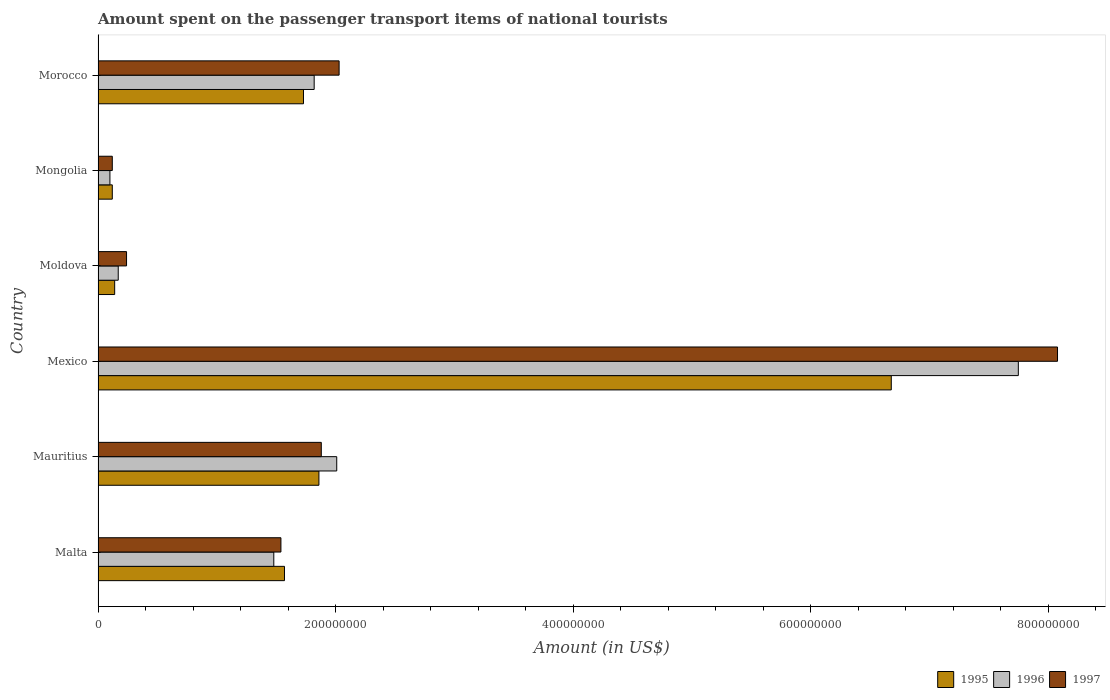Are the number of bars per tick equal to the number of legend labels?
Provide a succinct answer. Yes. How many bars are there on the 4th tick from the top?
Ensure brevity in your answer.  3. How many bars are there on the 1st tick from the bottom?
Give a very brief answer. 3. What is the label of the 3rd group of bars from the top?
Offer a very short reply. Moldova. What is the amount spent on the passenger transport items of national tourists in 1996 in Mauritius?
Offer a very short reply. 2.01e+08. Across all countries, what is the maximum amount spent on the passenger transport items of national tourists in 1995?
Your answer should be very brief. 6.68e+08. In which country was the amount spent on the passenger transport items of national tourists in 1995 minimum?
Ensure brevity in your answer.  Mongolia. What is the total amount spent on the passenger transport items of national tourists in 1995 in the graph?
Your answer should be compact. 1.21e+09. What is the difference between the amount spent on the passenger transport items of national tourists in 1995 in Mexico and that in Moldova?
Provide a short and direct response. 6.54e+08. What is the difference between the amount spent on the passenger transport items of national tourists in 1995 in Moldova and the amount spent on the passenger transport items of national tourists in 1997 in Mexico?
Your response must be concise. -7.94e+08. What is the average amount spent on the passenger transport items of national tourists in 1997 per country?
Keep it short and to the point. 2.32e+08. What is the ratio of the amount spent on the passenger transport items of national tourists in 1995 in Mauritius to that in Moldova?
Provide a succinct answer. 13.29. Is the difference between the amount spent on the passenger transport items of national tourists in 1995 in Mauritius and Mexico greater than the difference between the amount spent on the passenger transport items of national tourists in 1996 in Mauritius and Mexico?
Give a very brief answer. Yes. What is the difference between the highest and the second highest amount spent on the passenger transport items of national tourists in 1995?
Offer a very short reply. 4.82e+08. What is the difference between the highest and the lowest amount spent on the passenger transport items of national tourists in 1997?
Provide a succinct answer. 7.96e+08. Is the sum of the amount spent on the passenger transport items of national tourists in 1995 in Mauritius and Mongolia greater than the maximum amount spent on the passenger transport items of national tourists in 1996 across all countries?
Your answer should be very brief. No. What does the 2nd bar from the top in Malta represents?
Provide a short and direct response. 1996. Are all the bars in the graph horizontal?
Make the answer very short. Yes. How many countries are there in the graph?
Keep it short and to the point. 6. Does the graph contain any zero values?
Your response must be concise. No. Does the graph contain grids?
Your response must be concise. No. Where does the legend appear in the graph?
Offer a very short reply. Bottom right. How are the legend labels stacked?
Make the answer very short. Horizontal. What is the title of the graph?
Make the answer very short. Amount spent on the passenger transport items of national tourists. Does "2004" appear as one of the legend labels in the graph?
Offer a terse response. No. What is the label or title of the Y-axis?
Keep it short and to the point. Country. What is the Amount (in US$) of 1995 in Malta?
Offer a terse response. 1.57e+08. What is the Amount (in US$) in 1996 in Malta?
Provide a succinct answer. 1.48e+08. What is the Amount (in US$) in 1997 in Malta?
Your answer should be very brief. 1.54e+08. What is the Amount (in US$) in 1995 in Mauritius?
Provide a succinct answer. 1.86e+08. What is the Amount (in US$) in 1996 in Mauritius?
Offer a very short reply. 2.01e+08. What is the Amount (in US$) of 1997 in Mauritius?
Give a very brief answer. 1.88e+08. What is the Amount (in US$) in 1995 in Mexico?
Give a very brief answer. 6.68e+08. What is the Amount (in US$) in 1996 in Mexico?
Your response must be concise. 7.75e+08. What is the Amount (in US$) in 1997 in Mexico?
Ensure brevity in your answer.  8.08e+08. What is the Amount (in US$) in 1995 in Moldova?
Ensure brevity in your answer.  1.40e+07. What is the Amount (in US$) in 1996 in Moldova?
Make the answer very short. 1.70e+07. What is the Amount (in US$) of 1997 in Moldova?
Offer a very short reply. 2.40e+07. What is the Amount (in US$) of 1995 in Morocco?
Offer a terse response. 1.73e+08. What is the Amount (in US$) in 1996 in Morocco?
Offer a terse response. 1.82e+08. What is the Amount (in US$) in 1997 in Morocco?
Your response must be concise. 2.03e+08. Across all countries, what is the maximum Amount (in US$) in 1995?
Keep it short and to the point. 6.68e+08. Across all countries, what is the maximum Amount (in US$) of 1996?
Offer a very short reply. 7.75e+08. Across all countries, what is the maximum Amount (in US$) of 1997?
Ensure brevity in your answer.  8.08e+08. Across all countries, what is the minimum Amount (in US$) in 1995?
Offer a terse response. 1.20e+07. Across all countries, what is the minimum Amount (in US$) of 1996?
Your answer should be very brief. 1.00e+07. What is the total Amount (in US$) in 1995 in the graph?
Ensure brevity in your answer.  1.21e+09. What is the total Amount (in US$) in 1996 in the graph?
Keep it short and to the point. 1.33e+09. What is the total Amount (in US$) in 1997 in the graph?
Your answer should be very brief. 1.39e+09. What is the difference between the Amount (in US$) in 1995 in Malta and that in Mauritius?
Offer a very short reply. -2.90e+07. What is the difference between the Amount (in US$) in 1996 in Malta and that in Mauritius?
Your answer should be compact. -5.30e+07. What is the difference between the Amount (in US$) in 1997 in Malta and that in Mauritius?
Give a very brief answer. -3.40e+07. What is the difference between the Amount (in US$) of 1995 in Malta and that in Mexico?
Your answer should be compact. -5.11e+08. What is the difference between the Amount (in US$) of 1996 in Malta and that in Mexico?
Make the answer very short. -6.27e+08. What is the difference between the Amount (in US$) of 1997 in Malta and that in Mexico?
Offer a very short reply. -6.54e+08. What is the difference between the Amount (in US$) in 1995 in Malta and that in Moldova?
Your answer should be compact. 1.43e+08. What is the difference between the Amount (in US$) of 1996 in Malta and that in Moldova?
Your answer should be very brief. 1.31e+08. What is the difference between the Amount (in US$) in 1997 in Malta and that in Moldova?
Your answer should be compact. 1.30e+08. What is the difference between the Amount (in US$) in 1995 in Malta and that in Mongolia?
Offer a terse response. 1.45e+08. What is the difference between the Amount (in US$) of 1996 in Malta and that in Mongolia?
Provide a short and direct response. 1.38e+08. What is the difference between the Amount (in US$) of 1997 in Malta and that in Mongolia?
Your response must be concise. 1.42e+08. What is the difference between the Amount (in US$) of 1995 in Malta and that in Morocco?
Offer a terse response. -1.60e+07. What is the difference between the Amount (in US$) of 1996 in Malta and that in Morocco?
Provide a short and direct response. -3.40e+07. What is the difference between the Amount (in US$) of 1997 in Malta and that in Morocco?
Offer a terse response. -4.90e+07. What is the difference between the Amount (in US$) of 1995 in Mauritius and that in Mexico?
Offer a terse response. -4.82e+08. What is the difference between the Amount (in US$) of 1996 in Mauritius and that in Mexico?
Your response must be concise. -5.74e+08. What is the difference between the Amount (in US$) of 1997 in Mauritius and that in Mexico?
Make the answer very short. -6.20e+08. What is the difference between the Amount (in US$) in 1995 in Mauritius and that in Moldova?
Offer a very short reply. 1.72e+08. What is the difference between the Amount (in US$) of 1996 in Mauritius and that in Moldova?
Your answer should be very brief. 1.84e+08. What is the difference between the Amount (in US$) in 1997 in Mauritius and that in Moldova?
Keep it short and to the point. 1.64e+08. What is the difference between the Amount (in US$) in 1995 in Mauritius and that in Mongolia?
Offer a very short reply. 1.74e+08. What is the difference between the Amount (in US$) of 1996 in Mauritius and that in Mongolia?
Ensure brevity in your answer.  1.91e+08. What is the difference between the Amount (in US$) in 1997 in Mauritius and that in Mongolia?
Your answer should be very brief. 1.76e+08. What is the difference between the Amount (in US$) of 1995 in Mauritius and that in Morocco?
Offer a very short reply. 1.30e+07. What is the difference between the Amount (in US$) of 1996 in Mauritius and that in Morocco?
Provide a short and direct response. 1.90e+07. What is the difference between the Amount (in US$) of 1997 in Mauritius and that in Morocco?
Offer a very short reply. -1.50e+07. What is the difference between the Amount (in US$) of 1995 in Mexico and that in Moldova?
Offer a very short reply. 6.54e+08. What is the difference between the Amount (in US$) of 1996 in Mexico and that in Moldova?
Your answer should be very brief. 7.58e+08. What is the difference between the Amount (in US$) in 1997 in Mexico and that in Moldova?
Your answer should be very brief. 7.84e+08. What is the difference between the Amount (in US$) of 1995 in Mexico and that in Mongolia?
Your answer should be very brief. 6.56e+08. What is the difference between the Amount (in US$) of 1996 in Mexico and that in Mongolia?
Make the answer very short. 7.65e+08. What is the difference between the Amount (in US$) of 1997 in Mexico and that in Mongolia?
Your response must be concise. 7.96e+08. What is the difference between the Amount (in US$) of 1995 in Mexico and that in Morocco?
Offer a terse response. 4.95e+08. What is the difference between the Amount (in US$) in 1996 in Mexico and that in Morocco?
Your response must be concise. 5.93e+08. What is the difference between the Amount (in US$) in 1997 in Mexico and that in Morocco?
Offer a terse response. 6.05e+08. What is the difference between the Amount (in US$) in 1995 in Moldova and that in Mongolia?
Give a very brief answer. 2.00e+06. What is the difference between the Amount (in US$) of 1997 in Moldova and that in Mongolia?
Keep it short and to the point. 1.20e+07. What is the difference between the Amount (in US$) in 1995 in Moldova and that in Morocco?
Your response must be concise. -1.59e+08. What is the difference between the Amount (in US$) of 1996 in Moldova and that in Morocco?
Your answer should be very brief. -1.65e+08. What is the difference between the Amount (in US$) of 1997 in Moldova and that in Morocco?
Make the answer very short. -1.79e+08. What is the difference between the Amount (in US$) of 1995 in Mongolia and that in Morocco?
Give a very brief answer. -1.61e+08. What is the difference between the Amount (in US$) in 1996 in Mongolia and that in Morocco?
Give a very brief answer. -1.72e+08. What is the difference between the Amount (in US$) of 1997 in Mongolia and that in Morocco?
Make the answer very short. -1.91e+08. What is the difference between the Amount (in US$) in 1995 in Malta and the Amount (in US$) in 1996 in Mauritius?
Your answer should be very brief. -4.40e+07. What is the difference between the Amount (in US$) in 1995 in Malta and the Amount (in US$) in 1997 in Mauritius?
Your answer should be very brief. -3.10e+07. What is the difference between the Amount (in US$) of 1996 in Malta and the Amount (in US$) of 1997 in Mauritius?
Give a very brief answer. -4.00e+07. What is the difference between the Amount (in US$) in 1995 in Malta and the Amount (in US$) in 1996 in Mexico?
Give a very brief answer. -6.18e+08. What is the difference between the Amount (in US$) of 1995 in Malta and the Amount (in US$) of 1997 in Mexico?
Offer a very short reply. -6.51e+08. What is the difference between the Amount (in US$) in 1996 in Malta and the Amount (in US$) in 1997 in Mexico?
Make the answer very short. -6.60e+08. What is the difference between the Amount (in US$) of 1995 in Malta and the Amount (in US$) of 1996 in Moldova?
Offer a very short reply. 1.40e+08. What is the difference between the Amount (in US$) in 1995 in Malta and the Amount (in US$) in 1997 in Moldova?
Provide a succinct answer. 1.33e+08. What is the difference between the Amount (in US$) of 1996 in Malta and the Amount (in US$) of 1997 in Moldova?
Provide a short and direct response. 1.24e+08. What is the difference between the Amount (in US$) in 1995 in Malta and the Amount (in US$) in 1996 in Mongolia?
Offer a very short reply. 1.47e+08. What is the difference between the Amount (in US$) in 1995 in Malta and the Amount (in US$) in 1997 in Mongolia?
Offer a terse response. 1.45e+08. What is the difference between the Amount (in US$) of 1996 in Malta and the Amount (in US$) of 1997 in Mongolia?
Make the answer very short. 1.36e+08. What is the difference between the Amount (in US$) in 1995 in Malta and the Amount (in US$) in 1996 in Morocco?
Your response must be concise. -2.50e+07. What is the difference between the Amount (in US$) of 1995 in Malta and the Amount (in US$) of 1997 in Morocco?
Offer a very short reply. -4.60e+07. What is the difference between the Amount (in US$) in 1996 in Malta and the Amount (in US$) in 1997 in Morocco?
Your answer should be compact. -5.50e+07. What is the difference between the Amount (in US$) in 1995 in Mauritius and the Amount (in US$) in 1996 in Mexico?
Your answer should be compact. -5.89e+08. What is the difference between the Amount (in US$) of 1995 in Mauritius and the Amount (in US$) of 1997 in Mexico?
Provide a succinct answer. -6.22e+08. What is the difference between the Amount (in US$) of 1996 in Mauritius and the Amount (in US$) of 1997 in Mexico?
Your answer should be very brief. -6.07e+08. What is the difference between the Amount (in US$) of 1995 in Mauritius and the Amount (in US$) of 1996 in Moldova?
Keep it short and to the point. 1.69e+08. What is the difference between the Amount (in US$) of 1995 in Mauritius and the Amount (in US$) of 1997 in Moldova?
Ensure brevity in your answer.  1.62e+08. What is the difference between the Amount (in US$) in 1996 in Mauritius and the Amount (in US$) in 1997 in Moldova?
Provide a succinct answer. 1.77e+08. What is the difference between the Amount (in US$) in 1995 in Mauritius and the Amount (in US$) in 1996 in Mongolia?
Provide a short and direct response. 1.76e+08. What is the difference between the Amount (in US$) in 1995 in Mauritius and the Amount (in US$) in 1997 in Mongolia?
Your answer should be very brief. 1.74e+08. What is the difference between the Amount (in US$) of 1996 in Mauritius and the Amount (in US$) of 1997 in Mongolia?
Offer a terse response. 1.89e+08. What is the difference between the Amount (in US$) in 1995 in Mauritius and the Amount (in US$) in 1996 in Morocco?
Your answer should be compact. 4.00e+06. What is the difference between the Amount (in US$) in 1995 in Mauritius and the Amount (in US$) in 1997 in Morocco?
Your response must be concise. -1.70e+07. What is the difference between the Amount (in US$) in 1996 in Mauritius and the Amount (in US$) in 1997 in Morocco?
Provide a succinct answer. -2.00e+06. What is the difference between the Amount (in US$) in 1995 in Mexico and the Amount (in US$) in 1996 in Moldova?
Offer a very short reply. 6.51e+08. What is the difference between the Amount (in US$) of 1995 in Mexico and the Amount (in US$) of 1997 in Moldova?
Make the answer very short. 6.44e+08. What is the difference between the Amount (in US$) of 1996 in Mexico and the Amount (in US$) of 1997 in Moldova?
Ensure brevity in your answer.  7.51e+08. What is the difference between the Amount (in US$) in 1995 in Mexico and the Amount (in US$) in 1996 in Mongolia?
Give a very brief answer. 6.58e+08. What is the difference between the Amount (in US$) in 1995 in Mexico and the Amount (in US$) in 1997 in Mongolia?
Ensure brevity in your answer.  6.56e+08. What is the difference between the Amount (in US$) in 1996 in Mexico and the Amount (in US$) in 1997 in Mongolia?
Keep it short and to the point. 7.63e+08. What is the difference between the Amount (in US$) in 1995 in Mexico and the Amount (in US$) in 1996 in Morocco?
Give a very brief answer. 4.86e+08. What is the difference between the Amount (in US$) of 1995 in Mexico and the Amount (in US$) of 1997 in Morocco?
Your response must be concise. 4.65e+08. What is the difference between the Amount (in US$) of 1996 in Mexico and the Amount (in US$) of 1997 in Morocco?
Keep it short and to the point. 5.72e+08. What is the difference between the Amount (in US$) in 1995 in Moldova and the Amount (in US$) in 1996 in Mongolia?
Give a very brief answer. 4.00e+06. What is the difference between the Amount (in US$) in 1996 in Moldova and the Amount (in US$) in 1997 in Mongolia?
Your response must be concise. 5.00e+06. What is the difference between the Amount (in US$) in 1995 in Moldova and the Amount (in US$) in 1996 in Morocco?
Provide a short and direct response. -1.68e+08. What is the difference between the Amount (in US$) of 1995 in Moldova and the Amount (in US$) of 1997 in Morocco?
Keep it short and to the point. -1.89e+08. What is the difference between the Amount (in US$) of 1996 in Moldova and the Amount (in US$) of 1997 in Morocco?
Keep it short and to the point. -1.86e+08. What is the difference between the Amount (in US$) in 1995 in Mongolia and the Amount (in US$) in 1996 in Morocco?
Provide a short and direct response. -1.70e+08. What is the difference between the Amount (in US$) of 1995 in Mongolia and the Amount (in US$) of 1997 in Morocco?
Your answer should be compact. -1.91e+08. What is the difference between the Amount (in US$) in 1996 in Mongolia and the Amount (in US$) in 1997 in Morocco?
Give a very brief answer. -1.93e+08. What is the average Amount (in US$) of 1995 per country?
Make the answer very short. 2.02e+08. What is the average Amount (in US$) in 1996 per country?
Make the answer very short. 2.22e+08. What is the average Amount (in US$) in 1997 per country?
Ensure brevity in your answer.  2.32e+08. What is the difference between the Amount (in US$) in 1995 and Amount (in US$) in 1996 in Malta?
Give a very brief answer. 9.00e+06. What is the difference between the Amount (in US$) of 1996 and Amount (in US$) of 1997 in Malta?
Your answer should be compact. -6.00e+06. What is the difference between the Amount (in US$) of 1995 and Amount (in US$) of 1996 in Mauritius?
Ensure brevity in your answer.  -1.50e+07. What is the difference between the Amount (in US$) of 1996 and Amount (in US$) of 1997 in Mauritius?
Your answer should be compact. 1.30e+07. What is the difference between the Amount (in US$) of 1995 and Amount (in US$) of 1996 in Mexico?
Your response must be concise. -1.07e+08. What is the difference between the Amount (in US$) in 1995 and Amount (in US$) in 1997 in Mexico?
Make the answer very short. -1.40e+08. What is the difference between the Amount (in US$) in 1996 and Amount (in US$) in 1997 in Mexico?
Keep it short and to the point. -3.30e+07. What is the difference between the Amount (in US$) in 1995 and Amount (in US$) in 1996 in Moldova?
Give a very brief answer. -3.00e+06. What is the difference between the Amount (in US$) in 1995 and Amount (in US$) in 1997 in Moldova?
Your response must be concise. -1.00e+07. What is the difference between the Amount (in US$) of 1996 and Amount (in US$) of 1997 in Moldova?
Provide a succinct answer. -7.00e+06. What is the difference between the Amount (in US$) in 1995 and Amount (in US$) in 1997 in Mongolia?
Keep it short and to the point. 0. What is the difference between the Amount (in US$) of 1996 and Amount (in US$) of 1997 in Mongolia?
Ensure brevity in your answer.  -2.00e+06. What is the difference between the Amount (in US$) of 1995 and Amount (in US$) of 1996 in Morocco?
Provide a succinct answer. -9.00e+06. What is the difference between the Amount (in US$) in 1995 and Amount (in US$) in 1997 in Morocco?
Give a very brief answer. -3.00e+07. What is the difference between the Amount (in US$) of 1996 and Amount (in US$) of 1997 in Morocco?
Your answer should be very brief. -2.10e+07. What is the ratio of the Amount (in US$) in 1995 in Malta to that in Mauritius?
Your answer should be very brief. 0.84. What is the ratio of the Amount (in US$) in 1996 in Malta to that in Mauritius?
Provide a succinct answer. 0.74. What is the ratio of the Amount (in US$) of 1997 in Malta to that in Mauritius?
Your answer should be compact. 0.82. What is the ratio of the Amount (in US$) in 1995 in Malta to that in Mexico?
Provide a short and direct response. 0.23. What is the ratio of the Amount (in US$) of 1996 in Malta to that in Mexico?
Ensure brevity in your answer.  0.19. What is the ratio of the Amount (in US$) of 1997 in Malta to that in Mexico?
Ensure brevity in your answer.  0.19. What is the ratio of the Amount (in US$) of 1995 in Malta to that in Moldova?
Offer a very short reply. 11.21. What is the ratio of the Amount (in US$) in 1996 in Malta to that in Moldova?
Offer a terse response. 8.71. What is the ratio of the Amount (in US$) in 1997 in Malta to that in Moldova?
Provide a short and direct response. 6.42. What is the ratio of the Amount (in US$) in 1995 in Malta to that in Mongolia?
Keep it short and to the point. 13.08. What is the ratio of the Amount (in US$) of 1997 in Malta to that in Mongolia?
Your answer should be very brief. 12.83. What is the ratio of the Amount (in US$) of 1995 in Malta to that in Morocco?
Provide a succinct answer. 0.91. What is the ratio of the Amount (in US$) in 1996 in Malta to that in Morocco?
Offer a terse response. 0.81. What is the ratio of the Amount (in US$) in 1997 in Malta to that in Morocco?
Your answer should be compact. 0.76. What is the ratio of the Amount (in US$) of 1995 in Mauritius to that in Mexico?
Keep it short and to the point. 0.28. What is the ratio of the Amount (in US$) of 1996 in Mauritius to that in Mexico?
Make the answer very short. 0.26. What is the ratio of the Amount (in US$) in 1997 in Mauritius to that in Mexico?
Offer a very short reply. 0.23. What is the ratio of the Amount (in US$) in 1995 in Mauritius to that in Moldova?
Your answer should be very brief. 13.29. What is the ratio of the Amount (in US$) of 1996 in Mauritius to that in Moldova?
Make the answer very short. 11.82. What is the ratio of the Amount (in US$) of 1997 in Mauritius to that in Moldova?
Your answer should be compact. 7.83. What is the ratio of the Amount (in US$) of 1996 in Mauritius to that in Mongolia?
Provide a short and direct response. 20.1. What is the ratio of the Amount (in US$) of 1997 in Mauritius to that in Mongolia?
Keep it short and to the point. 15.67. What is the ratio of the Amount (in US$) in 1995 in Mauritius to that in Morocco?
Provide a succinct answer. 1.08. What is the ratio of the Amount (in US$) in 1996 in Mauritius to that in Morocco?
Provide a short and direct response. 1.1. What is the ratio of the Amount (in US$) of 1997 in Mauritius to that in Morocco?
Keep it short and to the point. 0.93. What is the ratio of the Amount (in US$) of 1995 in Mexico to that in Moldova?
Offer a very short reply. 47.71. What is the ratio of the Amount (in US$) of 1996 in Mexico to that in Moldova?
Your response must be concise. 45.59. What is the ratio of the Amount (in US$) of 1997 in Mexico to that in Moldova?
Offer a terse response. 33.67. What is the ratio of the Amount (in US$) of 1995 in Mexico to that in Mongolia?
Provide a short and direct response. 55.67. What is the ratio of the Amount (in US$) of 1996 in Mexico to that in Mongolia?
Provide a short and direct response. 77.5. What is the ratio of the Amount (in US$) in 1997 in Mexico to that in Mongolia?
Your answer should be very brief. 67.33. What is the ratio of the Amount (in US$) in 1995 in Mexico to that in Morocco?
Provide a short and direct response. 3.86. What is the ratio of the Amount (in US$) in 1996 in Mexico to that in Morocco?
Make the answer very short. 4.26. What is the ratio of the Amount (in US$) of 1997 in Mexico to that in Morocco?
Offer a terse response. 3.98. What is the ratio of the Amount (in US$) of 1996 in Moldova to that in Mongolia?
Your answer should be compact. 1.7. What is the ratio of the Amount (in US$) of 1997 in Moldova to that in Mongolia?
Your response must be concise. 2. What is the ratio of the Amount (in US$) in 1995 in Moldova to that in Morocco?
Your response must be concise. 0.08. What is the ratio of the Amount (in US$) of 1996 in Moldova to that in Morocco?
Offer a terse response. 0.09. What is the ratio of the Amount (in US$) of 1997 in Moldova to that in Morocco?
Your answer should be compact. 0.12. What is the ratio of the Amount (in US$) in 1995 in Mongolia to that in Morocco?
Your answer should be compact. 0.07. What is the ratio of the Amount (in US$) in 1996 in Mongolia to that in Morocco?
Make the answer very short. 0.05. What is the ratio of the Amount (in US$) in 1997 in Mongolia to that in Morocco?
Offer a very short reply. 0.06. What is the difference between the highest and the second highest Amount (in US$) in 1995?
Make the answer very short. 4.82e+08. What is the difference between the highest and the second highest Amount (in US$) of 1996?
Offer a very short reply. 5.74e+08. What is the difference between the highest and the second highest Amount (in US$) of 1997?
Offer a very short reply. 6.05e+08. What is the difference between the highest and the lowest Amount (in US$) in 1995?
Give a very brief answer. 6.56e+08. What is the difference between the highest and the lowest Amount (in US$) of 1996?
Offer a very short reply. 7.65e+08. What is the difference between the highest and the lowest Amount (in US$) of 1997?
Ensure brevity in your answer.  7.96e+08. 